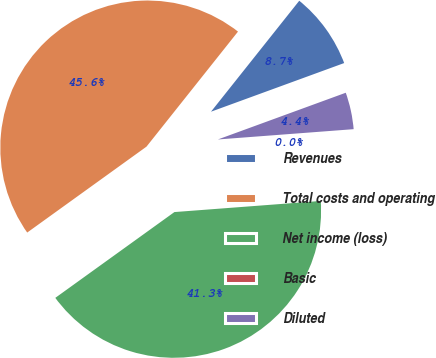Convert chart. <chart><loc_0><loc_0><loc_500><loc_500><pie_chart><fcel>Revenues<fcel>Total costs and operating<fcel>Net income (loss)<fcel>Basic<fcel>Diluted<nl><fcel>8.73%<fcel>45.63%<fcel>41.27%<fcel>0.0%<fcel>4.37%<nl></chart> 